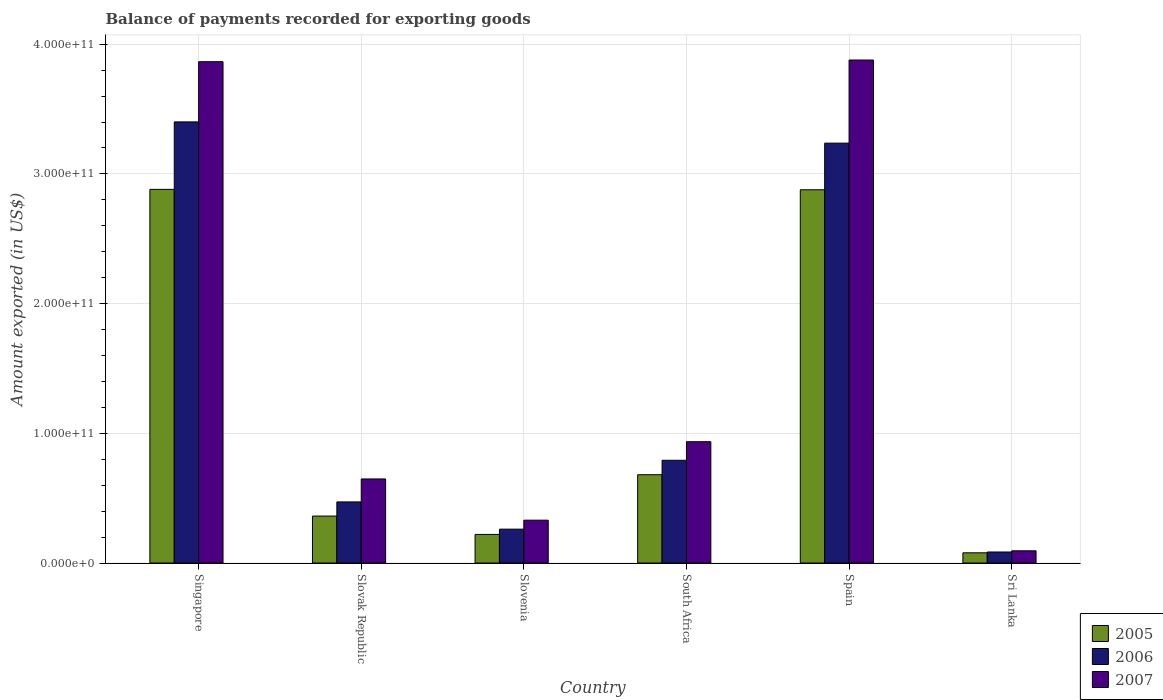How many different coloured bars are there?
Give a very brief answer. 3. How many groups of bars are there?
Offer a terse response. 6. Are the number of bars per tick equal to the number of legend labels?
Provide a short and direct response. Yes. Are the number of bars on each tick of the X-axis equal?
Provide a short and direct response. Yes. What is the label of the 5th group of bars from the left?
Your response must be concise. Spain. In how many cases, is the number of bars for a given country not equal to the number of legend labels?
Offer a very short reply. 0. What is the amount exported in 2006 in Singapore?
Offer a terse response. 3.40e+11. Across all countries, what is the maximum amount exported in 2005?
Give a very brief answer. 2.88e+11. Across all countries, what is the minimum amount exported in 2007?
Your response must be concise. 9.41e+09. In which country was the amount exported in 2005 maximum?
Your response must be concise. Singapore. In which country was the amount exported in 2005 minimum?
Ensure brevity in your answer.  Sri Lanka. What is the total amount exported in 2007 in the graph?
Keep it short and to the point. 9.75e+11. What is the difference between the amount exported in 2005 in Singapore and that in Sri Lanka?
Your answer should be very brief. 2.80e+11. What is the difference between the amount exported in 2006 in Singapore and the amount exported in 2007 in Slovak Republic?
Offer a terse response. 2.75e+11. What is the average amount exported in 2007 per country?
Provide a short and direct response. 1.63e+11. What is the difference between the amount exported of/in 2006 and amount exported of/in 2005 in South Africa?
Make the answer very short. 1.11e+1. In how many countries, is the amount exported in 2007 greater than 320000000000 US$?
Give a very brief answer. 2. What is the ratio of the amount exported in 2007 in Slovenia to that in South Africa?
Ensure brevity in your answer.  0.35. Is the amount exported in 2006 in South Africa less than that in Sri Lanka?
Your answer should be very brief. No. Is the difference between the amount exported in 2006 in Slovenia and Sri Lanka greater than the difference between the amount exported in 2005 in Slovenia and Sri Lanka?
Your response must be concise. Yes. What is the difference between the highest and the second highest amount exported in 2007?
Ensure brevity in your answer.  2.94e+11. What is the difference between the highest and the lowest amount exported in 2007?
Keep it short and to the point. 3.78e+11. Is the sum of the amount exported in 2006 in Slovenia and Spain greater than the maximum amount exported in 2007 across all countries?
Your answer should be very brief. No. How many countries are there in the graph?
Offer a very short reply. 6. What is the difference between two consecutive major ticks on the Y-axis?
Your answer should be compact. 1.00e+11. Are the values on the major ticks of Y-axis written in scientific E-notation?
Ensure brevity in your answer.  Yes. Where does the legend appear in the graph?
Keep it short and to the point. Bottom right. How many legend labels are there?
Ensure brevity in your answer.  3. How are the legend labels stacked?
Your response must be concise. Vertical. What is the title of the graph?
Offer a very short reply. Balance of payments recorded for exporting goods. Does "1987" appear as one of the legend labels in the graph?
Ensure brevity in your answer.  No. What is the label or title of the X-axis?
Your answer should be very brief. Country. What is the label or title of the Y-axis?
Offer a very short reply. Amount exported (in US$). What is the Amount exported (in US$) of 2005 in Singapore?
Ensure brevity in your answer.  2.88e+11. What is the Amount exported (in US$) of 2006 in Singapore?
Your answer should be very brief. 3.40e+11. What is the Amount exported (in US$) of 2007 in Singapore?
Offer a very short reply. 3.86e+11. What is the Amount exported (in US$) of 2005 in Slovak Republic?
Give a very brief answer. 3.62e+1. What is the Amount exported (in US$) of 2006 in Slovak Republic?
Your answer should be very brief. 4.71e+1. What is the Amount exported (in US$) in 2007 in Slovak Republic?
Your answer should be very brief. 6.48e+1. What is the Amount exported (in US$) of 2005 in Slovenia?
Your response must be concise. 2.21e+1. What is the Amount exported (in US$) of 2006 in Slovenia?
Provide a succinct answer. 2.61e+1. What is the Amount exported (in US$) of 2007 in Slovenia?
Offer a very short reply. 3.30e+1. What is the Amount exported (in US$) in 2005 in South Africa?
Provide a succinct answer. 6.81e+1. What is the Amount exported (in US$) in 2006 in South Africa?
Ensure brevity in your answer.  7.92e+1. What is the Amount exported (in US$) of 2007 in South Africa?
Provide a short and direct response. 9.35e+1. What is the Amount exported (in US$) of 2005 in Spain?
Ensure brevity in your answer.  2.88e+11. What is the Amount exported (in US$) in 2006 in Spain?
Your response must be concise. 3.24e+11. What is the Amount exported (in US$) in 2007 in Spain?
Ensure brevity in your answer.  3.88e+11. What is the Amount exported (in US$) in 2005 in Sri Lanka?
Give a very brief answer. 7.89e+09. What is the Amount exported (in US$) of 2006 in Sri Lanka?
Keep it short and to the point. 8.51e+09. What is the Amount exported (in US$) of 2007 in Sri Lanka?
Give a very brief answer. 9.41e+09. Across all countries, what is the maximum Amount exported (in US$) in 2005?
Give a very brief answer. 2.88e+11. Across all countries, what is the maximum Amount exported (in US$) in 2006?
Make the answer very short. 3.40e+11. Across all countries, what is the maximum Amount exported (in US$) in 2007?
Keep it short and to the point. 3.88e+11. Across all countries, what is the minimum Amount exported (in US$) in 2005?
Offer a terse response. 7.89e+09. Across all countries, what is the minimum Amount exported (in US$) of 2006?
Keep it short and to the point. 8.51e+09. Across all countries, what is the minimum Amount exported (in US$) in 2007?
Offer a very short reply. 9.41e+09. What is the total Amount exported (in US$) in 2005 in the graph?
Provide a succinct answer. 7.10e+11. What is the total Amount exported (in US$) of 2006 in the graph?
Provide a short and direct response. 8.25e+11. What is the total Amount exported (in US$) of 2007 in the graph?
Your answer should be compact. 9.75e+11. What is the difference between the Amount exported (in US$) in 2005 in Singapore and that in Slovak Republic?
Provide a succinct answer. 2.52e+11. What is the difference between the Amount exported (in US$) of 2006 in Singapore and that in Slovak Republic?
Provide a short and direct response. 2.93e+11. What is the difference between the Amount exported (in US$) in 2007 in Singapore and that in Slovak Republic?
Provide a succinct answer. 3.22e+11. What is the difference between the Amount exported (in US$) of 2005 in Singapore and that in Slovenia?
Give a very brief answer. 2.66e+11. What is the difference between the Amount exported (in US$) in 2006 in Singapore and that in Slovenia?
Provide a short and direct response. 3.14e+11. What is the difference between the Amount exported (in US$) of 2007 in Singapore and that in Slovenia?
Your response must be concise. 3.53e+11. What is the difference between the Amount exported (in US$) in 2005 in Singapore and that in South Africa?
Ensure brevity in your answer.  2.20e+11. What is the difference between the Amount exported (in US$) of 2006 in Singapore and that in South Africa?
Make the answer very short. 2.61e+11. What is the difference between the Amount exported (in US$) of 2007 in Singapore and that in South Africa?
Your response must be concise. 2.93e+11. What is the difference between the Amount exported (in US$) in 2005 in Singapore and that in Spain?
Give a very brief answer. 2.99e+08. What is the difference between the Amount exported (in US$) of 2006 in Singapore and that in Spain?
Offer a very short reply. 1.64e+1. What is the difference between the Amount exported (in US$) of 2007 in Singapore and that in Spain?
Your answer should be compact. -1.29e+09. What is the difference between the Amount exported (in US$) of 2005 in Singapore and that in Sri Lanka?
Provide a succinct answer. 2.80e+11. What is the difference between the Amount exported (in US$) in 2006 in Singapore and that in Sri Lanka?
Give a very brief answer. 3.32e+11. What is the difference between the Amount exported (in US$) in 2007 in Singapore and that in Sri Lanka?
Your response must be concise. 3.77e+11. What is the difference between the Amount exported (in US$) in 2005 in Slovak Republic and that in Slovenia?
Keep it short and to the point. 1.42e+1. What is the difference between the Amount exported (in US$) of 2006 in Slovak Republic and that in Slovenia?
Give a very brief answer. 2.10e+1. What is the difference between the Amount exported (in US$) in 2007 in Slovak Republic and that in Slovenia?
Your answer should be compact. 3.18e+1. What is the difference between the Amount exported (in US$) of 2005 in Slovak Republic and that in South Africa?
Make the answer very short. -3.19e+1. What is the difference between the Amount exported (in US$) in 2006 in Slovak Republic and that in South Africa?
Make the answer very short. -3.21e+1. What is the difference between the Amount exported (in US$) in 2007 in Slovak Republic and that in South Africa?
Give a very brief answer. -2.87e+1. What is the difference between the Amount exported (in US$) in 2005 in Slovak Republic and that in Spain?
Ensure brevity in your answer.  -2.52e+11. What is the difference between the Amount exported (in US$) of 2006 in Slovak Republic and that in Spain?
Give a very brief answer. -2.77e+11. What is the difference between the Amount exported (in US$) of 2007 in Slovak Republic and that in Spain?
Provide a succinct answer. -3.23e+11. What is the difference between the Amount exported (in US$) in 2005 in Slovak Republic and that in Sri Lanka?
Your response must be concise. 2.83e+1. What is the difference between the Amount exported (in US$) of 2006 in Slovak Republic and that in Sri Lanka?
Your answer should be very brief. 3.86e+1. What is the difference between the Amount exported (in US$) of 2007 in Slovak Republic and that in Sri Lanka?
Offer a very short reply. 5.54e+1. What is the difference between the Amount exported (in US$) in 2005 in Slovenia and that in South Africa?
Give a very brief answer. -4.60e+1. What is the difference between the Amount exported (in US$) of 2006 in Slovenia and that in South Africa?
Keep it short and to the point. -5.31e+1. What is the difference between the Amount exported (in US$) in 2007 in Slovenia and that in South Africa?
Your answer should be very brief. -6.05e+1. What is the difference between the Amount exported (in US$) of 2005 in Slovenia and that in Spain?
Offer a terse response. -2.66e+11. What is the difference between the Amount exported (in US$) in 2006 in Slovenia and that in Spain?
Keep it short and to the point. -2.98e+11. What is the difference between the Amount exported (in US$) in 2007 in Slovenia and that in Spain?
Your answer should be very brief. -3.55e+11. What is the difference between the Amount exported (in US$) of 2005 in Slovenia and that in Sri Lanka?
Keep it short and to the point. 1.42e+1. What is the difference between the Amount exported (in US$) in 2006 in Slovenia and that in Sri Lanka?
Give a very brief answer. 1.76e+1. What is the difference between the Amount exported (in US$) of 2007 in Slovenia and that in Sri Lanka?
Offer a very short reply. 2.36e+1. What is the difference between the Amount exported (in US$) in 2005 in South Africa and that in Spain?
Offer a terse response. -2.20e+11. What is the difference between the Amount exported (in US$) in 2006 in South Africa and that in Spain?
Provide a short and direct response. -2.44e+11. What is the difference between the Amount exported (in US$) of 2007 in South Africa and that in Spain?
Offer a very short reply. -2.94e+11. What is the difference between the Amount exported (in US$) of 2005 in South Africa and that in Sri Lanka?
Your response must be concise. 6.02e+1. What is the difference between the Amount exported (in US$) in 2006 in South Africa and that in Sri Lanka?
Your response must be concise. 7.07e+1. What is the difference between the Amount exported (in US$) in 2007 in South Africa and that in Sri Lanka?
Ensure brevity in your answer.  8.41e+1. What is the difference between the Amount exported (in US$) in 2005 in Spain and that in Sri Lanka?
Your answer should be compact. 2.80e+11. What is the difference between the Amount exported (in US$) of 2006 in Spain and that in Sri Lanka?
Your response must be concise. 3.15e+11. What is the difference between the Amount exported (in US$) in 2007 in Spain and that in Sri Lanka?
Offer a very short reply. 3.78e+11. What is the difference between the Amount exported (in US$) of 2005 in Singapore and the Amount exported (in US$) of 2006 in Slovak Republic?
Give a very brief answer. 2.41e+11. What is the difference between the Amount exported (in US$) of 2005 in Singapore and the Amount exported (in US$) of 2007 in Slovak Republic?
Offer a terse response. 2.23e+11. What is the difference between the Amount exported (in US$) of 2006 in Singapore and the Amount exported (in US$) of 2007 in Slovak Republic?
Keep it short and to the point. 2.75e+11. What is the difference between the Amount exported (in US$) in 2005 in Singapore and the Amount exported (in US$) in 2006 in Slovenia?
Keep it short and to the point. 2.62e+11. What is the difference between the Amount exported (in US$) of 2005 in Singapore and the Amount exported (in US$) of 2007 in Slovenia?
Provide a short and direct response. 2.55e+11. What is the difference between the Amount exported (in US$) of 2006 in Singapore and the Amount exported (in US$) of 2007 in Slovenia?
Provide a short and direct response. 3.07e+11. What is the difference between the Amount exported (in US$) in 2005 in Singapore and the Amount exported (in US$) in 2006 in South Africa?
Your response must be concise. 2.09e+11. What is the difference between the Amount exported (in US$) of 2005 in Singapore and the Amount exported (in US$) of 2007 in South Africa?
Offer a terse response. 1.95e+11. What is the difference between the Amount exported (in US$) of 2006 in Singapore and the Amount exported (in US$) of 2007 in South Africa?
Provide a succinct answer. 2.47e+11. What is the difference between the Amount exported (in US$) of 2005 in Singapore and the Amount exported (in US$) of 2006 in Spain?
Offer a very short reply. -3.56e+1. What is the difference between the Amount exported (in US$) in 2005 in Singapore and the Amount exported (in US$) in 2007 in Spain?
Keep it short and to the point. -9.97e+1. What is the difference between the Amount exported (in US$) of 2006 in Singapore and the Amount exported (in US$) of 2007 in Spain?
Provide a short and direct response. -4.77e+1. What is the difference between the Amount exported (in US$) of 2005 in Singapore and the Amount exported (in US$) of 2006 in Sri Lanka?
Your answer should be compact. 2.80e+11. What is the difference between the Amount exported (in US$) in 2005 in Singapore and the Amount exported (in US$) in 2007 in Sri Lanka?
Provide a short and direct response. 2.79e+11. What is the difference between the Amount exported (in US$) in 2006 in Singapore and the Amount exported (in US$) in 2007 in Sri Lanka?
Make the answer very short. 3.31e+11. What is the difference between the Amount exported (in US$) of 2005 in Slovak Republic and the Amount exported (in US$) of 2006 in Slovenia?
Give a very brief answer. 1.01e+1. What is the difference between the Amount exported (in US$) in 2005 in Slovak Republic and the Amount exported (in US$) in 2007 in Slovenia?
Make the answer very short. 3.18e+09. What is the difference between the Amount exported (in US$) of 2006 in Slovak Republic and the Amount exported (in US$) of 2007 in Slovenia?
Make the answer very short. 1.41e+1. What is the difference between the Amount exported (in US$) in 2005 in Slovak Republic and the Amount exported (in US$) in 2006 in South Africa?
Make the answer very short. -4.30e+1. What is the difference between the Amount exported (in US$) in 2005 in Slovak Republic and the Amount exported (in US$) in 2007 in South Africa?
Keep it short and to the point. -5.73e+1. What is the difference between the Amount exported (in US$) in 2006 in Slovak Republic and the Amount exported (in US$) in 2007 in South Africa?
Your response must be concise. -4.64e+1. What is the difference between the Amount exported (in US$) in 2005 in Slovak Republic and the Amount exported (in US$) in 2006 in Spain?
Your response must be concise. -2.87e+11. What is the difference between the Amount exported (in US$) of 2005 in Slovak Republic and the Amount exported (in US$) of 2007 in Spain?
Your answer should be compact. -3.52e+11. What is the difference between the Amount exported (in US$) in 2006 in Slovak Republic and the Amount exported (in US$) in 2007 in Spain?
Offer a terse response. -3.41e+11. What is the difference between the Amount exported (in US$) of 2005 in Slovak Republic and the Amount exported (in US$) of 2006 in Sri Lanka?
Ensure brevity in your answer.  2.77e+1. What is the difference between the Amount exported (in US$) in 2005 in Slovak Republic and the Amount exported (in US$) in 2007 in Sri Lanka?
Offer a very short reply. 2.68e+1. What is the difference between the Amount exported (in US$) of 2006 in Slovak Republic and the Amount exported (in US$) of 2007 in Sri Lanka?
Offer a terse response. 3.77e+1. What is the difference between the Amount exported (in US$) of 2005 in Slovenia and the Amount exported (in US$) of 2006 in South Africa?
Provide a short and direct response. -5.72e+1. What is the difference between the Amount exported (in US$) in 2005 in Slovenia and the Amount exported (in US$) in 2007 in South Africa?
Offer a very short reply. -7.15e+1. What is the difference between the Amount exported (in US$) of 2006 in Slovenia and the Amount exported (in US$) of 2007 in South Africa?
Your answer should be very brief. -6.74e+1. What is the difference between the Amount exported (in US$) of 2005 in Slovenia and the Amount exported (in US$) of 2006 in Spain?
Ensure brevity in your answer.  -3.02e+11. What is the difference between the Amount exported (in US$) of 2005 in Slovenia and the Amount exported (in US$) of 2007 in Spain?
Provide a short and direct response. -3.66e+11. What is the difference between the Amount exported (in US$) in 2006 in Slovenia and the Amount exported (in US$) in 2007 in Spain?
Ensure brevity in your answer.  -3.62e+11. What is the difference between the Amount exported (in US$) of 2005 in Slovenia and the Amount exported (in US$) of 2006 in Sri Lanka?
Make the answer very short. 1.35e+1. What is the difference between the Amount exported (in US$) in 2005 in Slovenia and the Amount exported (in US$) in 2007 in Sri Lanka?
Keep it short and to the point. 1.26e+1. What is the difference between the Amount exported (in US$) in 2006 in Slovenia and the Amount exported (in US$) in 2007 in Sri Lanka?
Ensure brevity in your answer.  1.67e+1. What is the difference between the Amount exported (in US$) of 2005 in South Africa and the Amount exported (in US$) of 2006 in Spain?
Provide a succinct answer. -2.56e+11. What is the difference between the Amount exported (in US$) of 2005 in South Africa and the Amount exported (in US$) of 2007 in Spain?
Your answer should be compact. -3.20e+11. What is the difference between the Amount exported (in US$) in 2006 in South Africa and the Amount exported (in US$) in 2007 in Spain?
Your response must be concise. -3.09e+11. What is the difference between the Amount exported (in US$) of 2005 in South Africa and the Amount exported (in US$) of 2006 in Sri Lanka?
Give a very brief answer. 5.96e+1. What is the difference between the Amount exported (in US$) in 2005 in South Africa and the Amount exported (in US$) in 2007 in Sri Lanka?
Give a very brief answer. 5.87e+1. What is the difference between the Amount exported (in US$) in 2006 in South Africa and the Amount exported (in US$) in 2007 in Sri Lanka?
Your answer should be very brief. 6.98e+1. What is the difference between the Amount exported (in US$) in 2005 in Spain and the Amount exported (in US$) in 2006 in Sri Lanka?
Offer a very short reply. 2.79e+11. What is the difference between the Amount exported (in US$) in 2005 in Spain and the Amount exported (in US$) in 2007 in Sri Lanka?
Your answer should be compact. 2.78e+11. What is the difference between the Amount exported (in US$) in 2006 in Spain and the Amount exported (in US$) in 2007 in Sri Lanka?
Make the answer very short. 3.14e+11. What is the average Amount exported (in US$) of 2005 per country?
Your answer should be compact. 1.18e+11. What is the average Amount exported (in US$) in 2006 per country?
Keep it short and to the point. 1.37e+11. What is the average Amount exported (in US$) of 2007 per country?
Offer a terse response. 1.63e+11. What is the difference between the Amount exported (in US$) in 2005 and Amount exported (in US$) in 2006 in Singapore?
Keep it short and to the point. -5.20e+1. What is the difference between the Amount exported (in US$) in 2005 and Amount exported (in US$) in 2007 in Singapore?
Keep it short and to the point. -9.84e+1. What is the difference between the Amount exported (in US$) in 2006 and Amount exported (in US$) in 2007 in Singapore?
Offer a very short reply. -4.64e+1. What is the difference between the Amount exported (in US$) in 2005 and Amount exported (in US$) in 2006 in Slovak Republic?
Your response must be concise. -1.09e+1. What is the difference between the Amount exported (in US$) in 2005 and Amount exported (in US$) in 2007 in Slovak Republic?
Your response must be concise. -2.86e+1. What is the difference between the Amount exported (in US$) of 2006 and Amount exported (in US$) of 2007 in Slovak Republic?
Your answer should be compact. -1.77e+1. What is the difference between the Amount exported (in US$) of 2005 and Amount exported (in US$) of 2006 in Slovenia?
Give a very brief answer. -4.07e+09. What is the difference between the Amount exported (in US$) of 2005 and Amount exported (in US$) of 2007 in Slovenia?
Ensure brevity in your answer.  -1.10e+1. What is the difference between the Amount exported (in US$) of 2006 and Amount exported (in US$) of 2007 in Slovenia?
Offer a very short reply. -6.91e+09. What is the difference between the Amount exported (in US$) of 2005 and Amount exported (in US$) of 2006 in South Africa?
Your answer should be very brief. -1.11e+1. What is the difference between the Amount exported (in US$) in 2005 and Amount exported (in US$) in 2007 in South Africa?
Offer a terse response. -2.54e+1. What is the difference between the Amount exported (in US$) of 2006 and Amount exported (in US$) of 2007 in South Africa?
Offer a very short reply. -1.43e+1. What is the difference between the Amount exported (in US$) of 2005 and Amount exported (in US$) of 2006 in Spain?
Provide a succinct answer. -3.59e+1. What is the difference between the Amount exported (in US$) of 2005 and Amount exported (in US$) of 2007 in Spain?
Your response must be concise. -1.00e+11. What is the difference between the Amount exported (in US$) of 2006 and Amount exported (in US$) of 2007 in Spain?
Offer a terse response. -6.41e+1. What is the difference between the Amount exported (in US$) of 2005 and Amount exported (in US$) of 2006 in Sri Lanka?
Give a very brief answer. -6.21e+08. What is the difference between the Amount exported (in US$) in 2005 and Amount exported (in US$) in 2007 in Sri Lanka?
Your response must be concise. -1.53e+09. What is the difference between the Amount exported (in US$) of 2006 and Amount exported (in US$) of 2007 in Sri Lanka?
Provide a short and direct response. -9.07e+08. What is the ratio of the Amount exported (in US$) in 2005 in Singapore to that in Slovak Republic?
Offer a terse response. 7.95. What is the ratio of the Amount exported (in US$) of 2006 in Singapore to that in Slovak Republic?
Make the answer very short. 7.22. What is the ratio of the Amount exported (in US$) in 2007 in Singapore to that in Slovak Republic?
Your answer should be very brief. 5.96. What is the ratio of the Amount exported (in US$) in 2005 in Singapore to that in Slovenia?
Provide a short and direct response. 13.06. What is the ratio of the Amount exported (in US$) of 2006 in Singapore to that in Slovenia?
Make the answer very short. 13.02. What is the ratio of the Amount exported (in US$) in 2007 in Singapore to that in Slovenia?
Your answer should be compact. 11.7. What is the ratio of the Amount exported (in US$) in 2005 in Singapore to that in South Africa?
Keep it short and to the point. 4.23. What is the ratio of the Amount exported (in US$) in 2006 in Singapore to that in South Africa?
Provide a succinct answer. 4.29. What is the ratio of the Amount exported (in US$) in 2007 in Singapore to that in South Africa?
Provide a succinct answer. 4.13. What is the ratio of the Amount exported (in US$) of 2006 in Singapore to that in Spain?
Ensure brevity in your answer.  1.05. What is the ratio of the Amount exported (in US$) in 2007 in Singapore to that in Spain?
Provide a short and direct response. 1. What is the ratio of the Amount exported (in US$) in 2005 in Singapore to that in Sri Lanka?
Your answer should be very brief. 36.52. What is the ratio of the Amount exported (in US$) in 2006 in Singapore to that in Sri Lanka?
Your answer should be compact. 39.97. What is the ratio of the Amount exported (in US$) in 2007 in Singapore to that in Sri Lanka?
Your response must be concise. 41.05. What is the ratio of the Amount exported (in US$) in 2005 in Slovak Republic to that in Slovenia?
Your answer should be very brief. 1.64. What is the ratio of the Amount exported (in US$) in 2006 in Slovak Republic to that in Slovenia?
Keep it short and to the point. 1.8. What is the ratio of the Amount exported (in US$) of 2007 in Slovak Republic to that in Slovenia?
Give a very brief answer. 1.96. What is the ratio of the Amount exported (in US$) of 2005 in Slovak Republic to that in South Africa?
Make the answer very short. 0.53. What is the ratio of the Amount exported (in US$) of 2006 in Slovak Republic to that in South Africa?
Provide a succinct answer. 0.59. What is the ratio of the Amount exported (in US$) of 2007 in Slovak Republic to that in South Africa?
Your response must be concise. 0.69. What is the ratio of the Amount exported (in US$) in 2005 in Slovak Republic to that in Spain?
Your response must be concise. 0.13. What is the ratio of the Amount exported (in US$) of 2006 in Slovak Republic to that in Spain?
Give a very brief answer. 0.15. What is the ratio of the Amount exported (in US$) of 2007 in Slovak Republic to that in Spain?
Your response must be concise. 0.17. What is the ratio of the Amount exported (in US$) in 2005 in Slovak Republic to that in Sri Lanka?
Provide a succinct answer. 4.59. What is the ratio of the Amount exported (in US$) in 2006 in Slovak Republic to that in Sri Lanka?
Provide a short and direct response. 5.54. What is the ratio of the Amount exported (in US$) in 2007 in Slovak Republic to that in Sri Lanka?
Your answer should be compact. 6.89. What is the ratio of the Amount exported (in US$) of 2005 in Slovenia to that in South Africa?
Provide a short and direct response. 0.32. What is the ratio of the Amount exported (in US$) of 2006 in Slovenia to that in South Africa?
Give a very brief answer. 0.33. What is the ratio of the Amount exported (in US$) in 2007 in Slovenia to that in South Africa?
Offer a very short reply. 0.35. What is the ratio of the Amount exported (in US$) in 2005 in Slovenia to that in Spain?
Make the answer very short. 0.08. What is the ratio of the Amount exported (in US$) in 2006 in Slovenia to that in Spain?
Make the answer very short. 0.08. What is the ratio of the Amount exported (in US$) of 2007 in Slovenia to that in Spain?
Give a very brief answer. 0.09. What is the ratio of the Amount exported (in US$) in 2005 in Slovenia to that in Sri Lanka?
Your answer should be compact. 2.8. What is the ratio of the Amount exported (in US$) of 2006 in Slovenia to that in Sri Lanka?
Your answer should be very brief. 3.07. What is the ratio of the Amount exported (in US$) of 2007 in Slovenia to that in Sri Lanka?
Offer a very short reply. 3.51. What is the ratio of the Amount exported (in US$) of 2005 in South Africa to that in Spain?
Make the answer very short. 0.24. What is the ratio of the Amount exported (in US$) of 2006 in South Africa to that in Spain?
Provide a short and direct response. 0.24. What is the ratio of the Amount exported (in US$) of 2007 in South Africa to that in Spain?
Ensure brevity in your answer.  0.24. What is the ratio of the Amount exported (in US$) in 2005 in South Africa to that in Sri Lanka?
Make the answer very short. 8.63. What is the ratio of the Amount exported (in US$) in 2006 in South Africa to that in Sri Lanka?
Give a very brief answer. 9.31. What is the ratio of the Amount exported (in US$) of 2007 in South Africa to that in Sri Lanka?
Your answer should be compact. 9.93. What is the ratio of the Amount exported (in US$) in 2005 in Spain to that in Sri Lanka?
Ensure brevity in your answer.  36.49. What is the ratio of the Amount exported (in US$) in 2006 in Spain to that in Sri Lanka?
Give a very brief answer. 38.05. What is the ratio of the Amount exported (in US$) of 2007 in Spain to that in Sri Lanka?
Make the answer very short. 41.19. What is the difference between the highest and the second highest Amount exported (in US$) in 2005?
Give a very brief answer. 2.99e+08. What is the difference between the highest and the second highest Amount exported (in US$) of 2006?
Keep it short and to the point. 1.64e+1. What is the difference between the highest and the second highest Amount exported (in US$) of 2007?
Provide a short and direct response. 1.29e+09. What is the difference between the highest and the lowest Amount exported (in US$) of 2005?
Your response must be concise. 2.80e+11. What is the difference between the highest and the lowest Amount exported (in US$) of 2006?
Offer a terse response. 3.32e+11. What is the difference between the highest and the lowest Amount exported (in US$) of 2007?
Keep it short and to the point. 3.78e+11. 